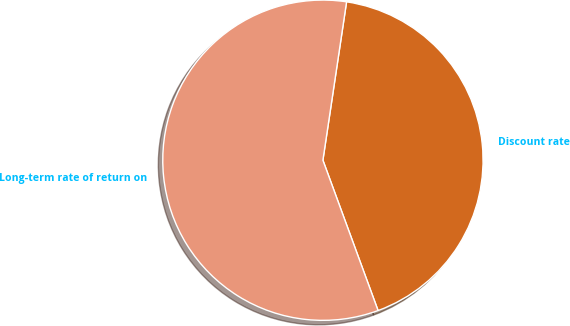<chart> <loc_0><loc_0><loc_500><loc_500><pie_chart><fcel>Discount rate<fcel>Long-term rate of return on<nl><fcel>42.04%<fcel>57.96%<nl></chart> 